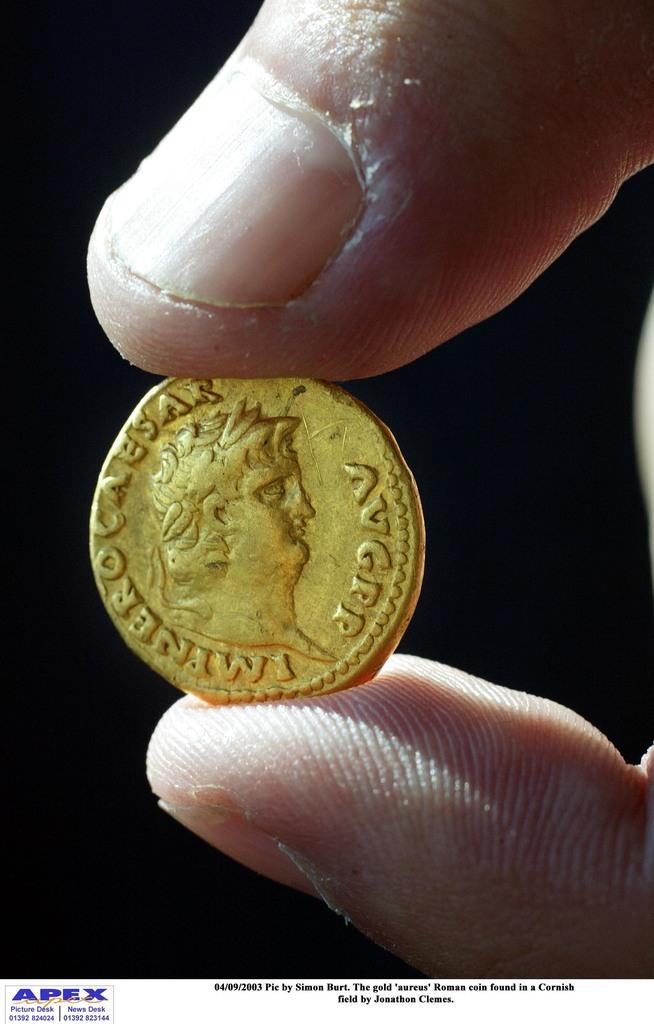Provide a one-sentence caption for the provided image. A gold coin with a Caesar written on it. 